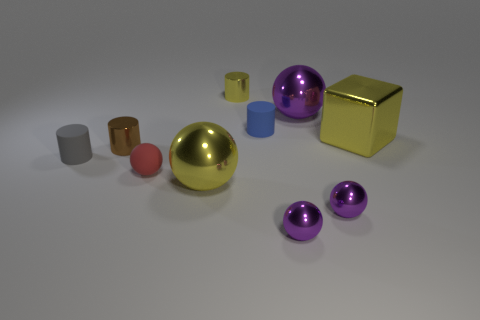Is there anything else that is made of the same material as the small brown cylinder?
Your response must be concise. Yes. What color is the big metallic block?
Offer a terse response. Yellow. What shape is the large thing that is the same color as the metallic block?
Your answer should be compact. Sphere. The rubber ball that is the same size as the brown object is what color?
Offer a terse response. Red. What number of metal things are yellow cubes or gray cylinders?
Your answer should be compact. 1. What number of metallic cylinders are both right of the brown object and in front of the small yellow cylinder?
Give a very brief answer. 0. How many other things are the same size as the blue cylinder?
Your answer should be compact. 6. Do the purple sphere left of the large purple shiny ball and the metal cylinder that is behind the yellow shiny cube have the same size?
Provide a succinct answer. Yes. What number of things are either metal blocks or shiny things to the right of the tiny brown cylinder?
Offer a terse response. 6. What size is the cylinder on the right side of the yellow cylinder?
Your answer should be very brief. Small. 